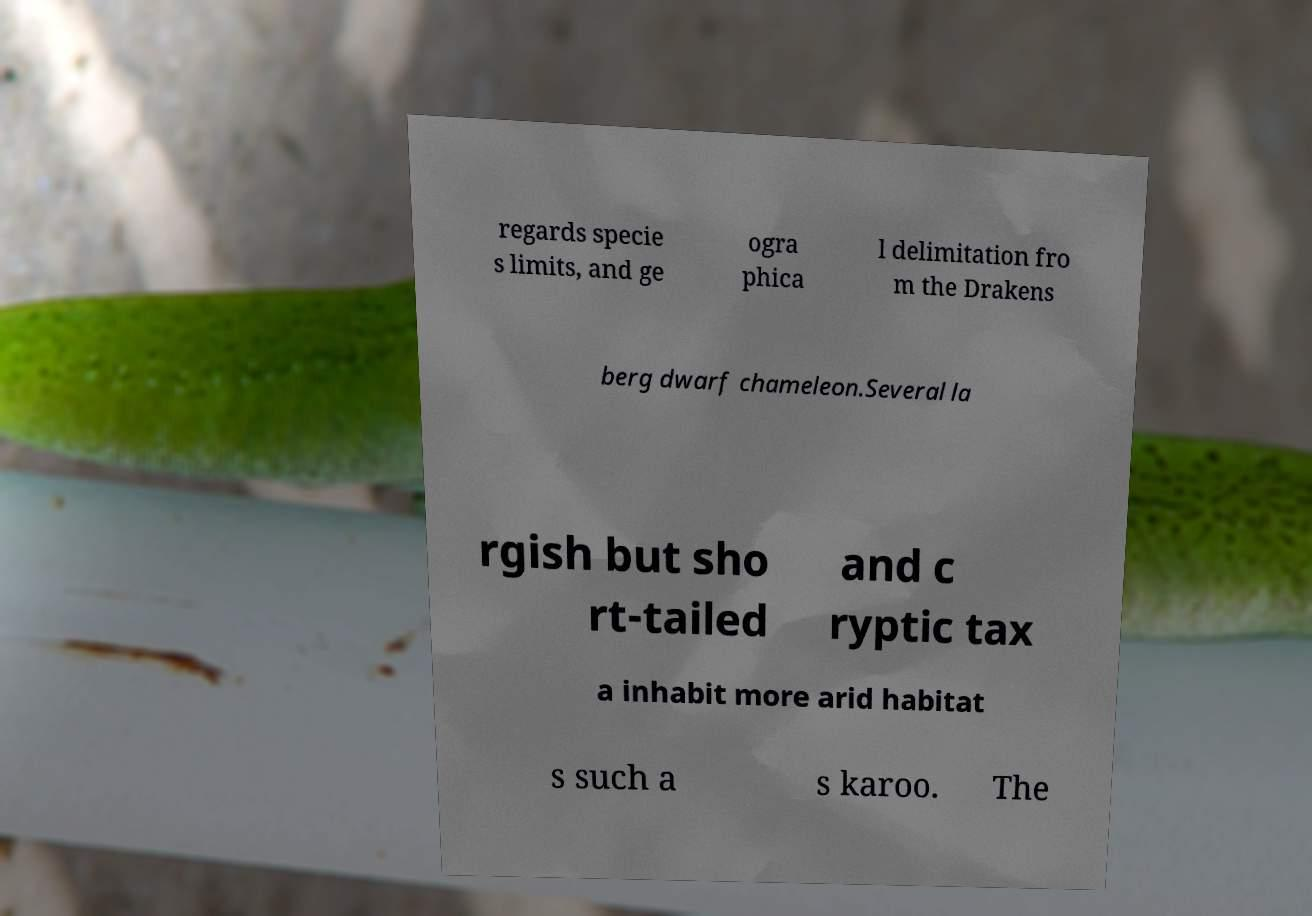For documentation purposes, I need the text within this image transcribed. Could you provide that? regards specie s limits, and ge ogra phica l delimitation fro m the Drakens berg dwarf chameleon.Several la rgish but sho rt-tailed and c ryptic tax a inhabit more arid habitat s such a s karoo. The 